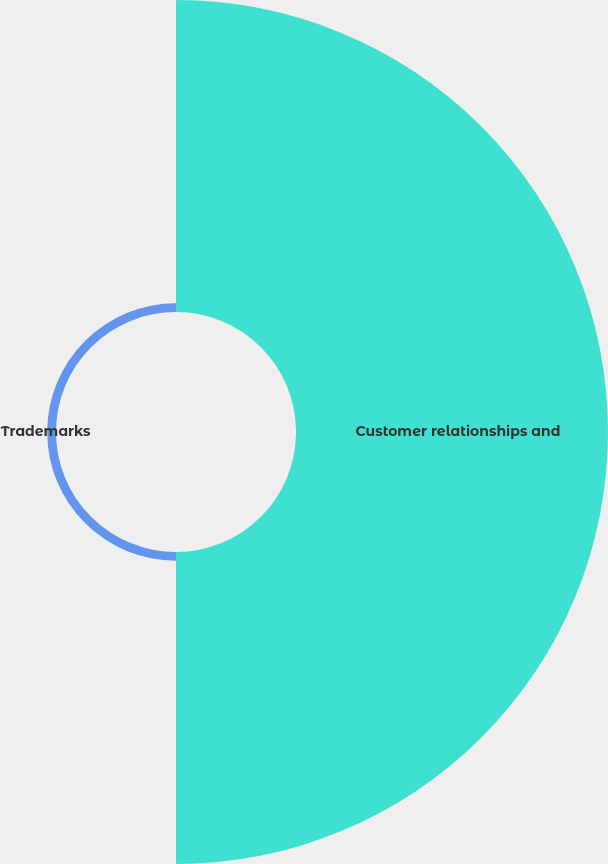<chart> <loc_0><loc_0><loc_500><loc_500><pie_chart><fcel>Customer relationships and<fcel>Trademarks<nl><fcel>97.25%<fcel>2.75%<nl></chart> 